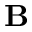Convert formula to latex. <formula><loc_0><loc_0><loc_500><loc_500>{ B }</formula> 